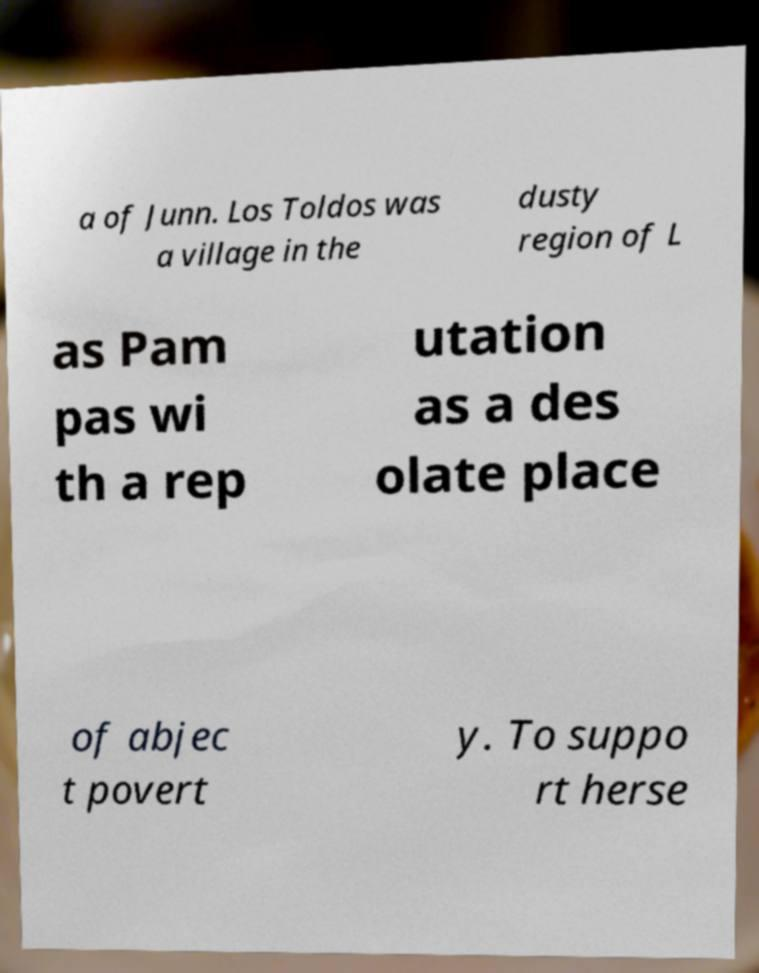I need the written content from this picture converted into text. Can you do that? a of Junn. Los Toldos was a village in the dusty region of L as Pam pas wi th a rep utation as a des olate place of abjec t povert y. To suppo rt herse 